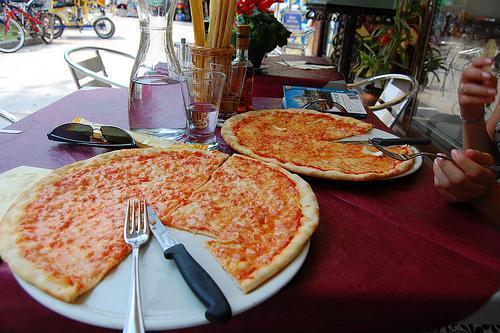How many pizzas?
Give a very brief answer. 2. How many forks are on the plate?
Give a very brief answer. 1. How many hands are in the picture?
Give a very brief answer. 2. How many pizzas are there?
Give a very brief answer. 2. 